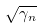<formula> <loc_0><loc_0><loc_500><loc_500>\sqrt { \gamma _ { n } }</formula> 